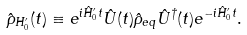<formula> <loc_0><loc_0><loc_500><loc_500>\hat { \rho } _ { H _ { 0 } ^ { \prime } } ( t ) \equiv e ^ { i \hat { H } _ { 0 } ^ { \prime } t } \hat { U } ( t ) \hat { \rho } _ { e q } \hat { U } ^ { \dagger } ( t ) e ^ { - i \hat { H } _ { 0 } ^ { \prime } t } .</formula> 